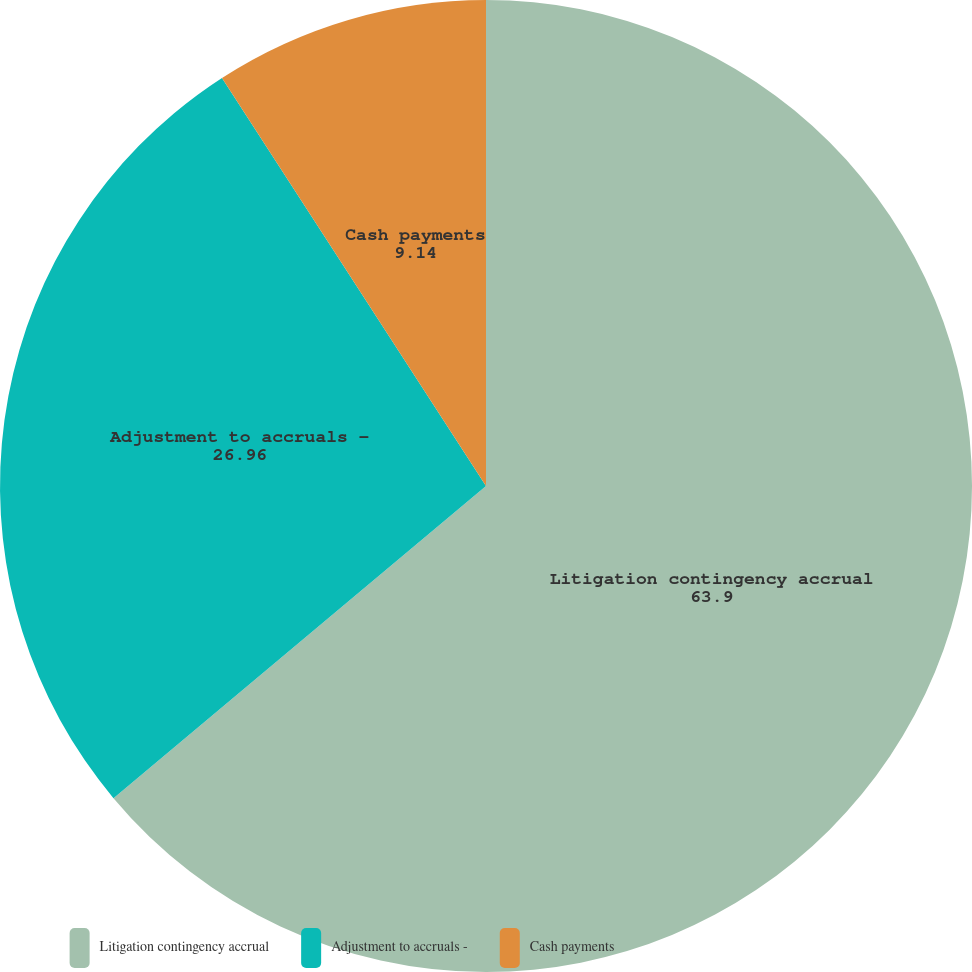Convert chart. <chart><loc_0><loc_0><loc_500><loc_500><pie_chart><fcel>Litigation contingency accrual<fcel>Adjustment to accruals -<fcel>Cash payments<nl><fcel>63.9%<fcel>26.96%<fcel>9.14%<nl></chart> 